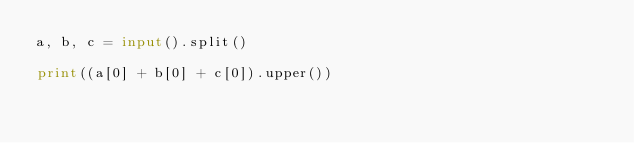Convert code to text. <code><loc_0><loc_0><loc_500><loc_500><_Python_>a, b, c = input().split()

print((a[0] + b[0] + c[0]).upper())</code> 